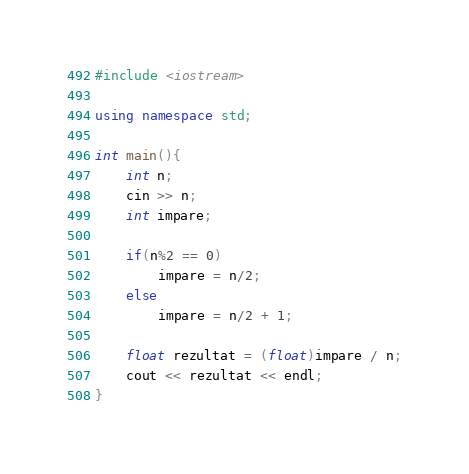Convert code to text. <code><loc_0><loc_0><loc_500><loc_500><_C++_>#include <iostream>

using namespace std;

int main(){
    int n;
    cin >> n;
    int impare;

    if(n%2 == 0)
        impare = n/2;
    else
        impare = n/2 + 1;

    float rezultat = (float)impare / n;
    cout << rezultat << endl;
}</code> 